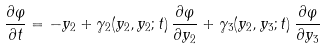Convert formula to latex. <formula><loc_0><loc_0><loc_500><loc_500>\frac { \partial \varphi } { \partial t } = - y _ { 2 } + \gamma _ { 2 } ( y _ { 2 } , y _ { 2 } ; t ) \, \frac { \partial \varphi } { \partial y _ { 2 } } + \gamma _ { 3 } ( y _ { 2 } , y _ { 3 } ; t ) \, \frac { \partial \varphi } { \partial y _ { 3 } }</formula> 